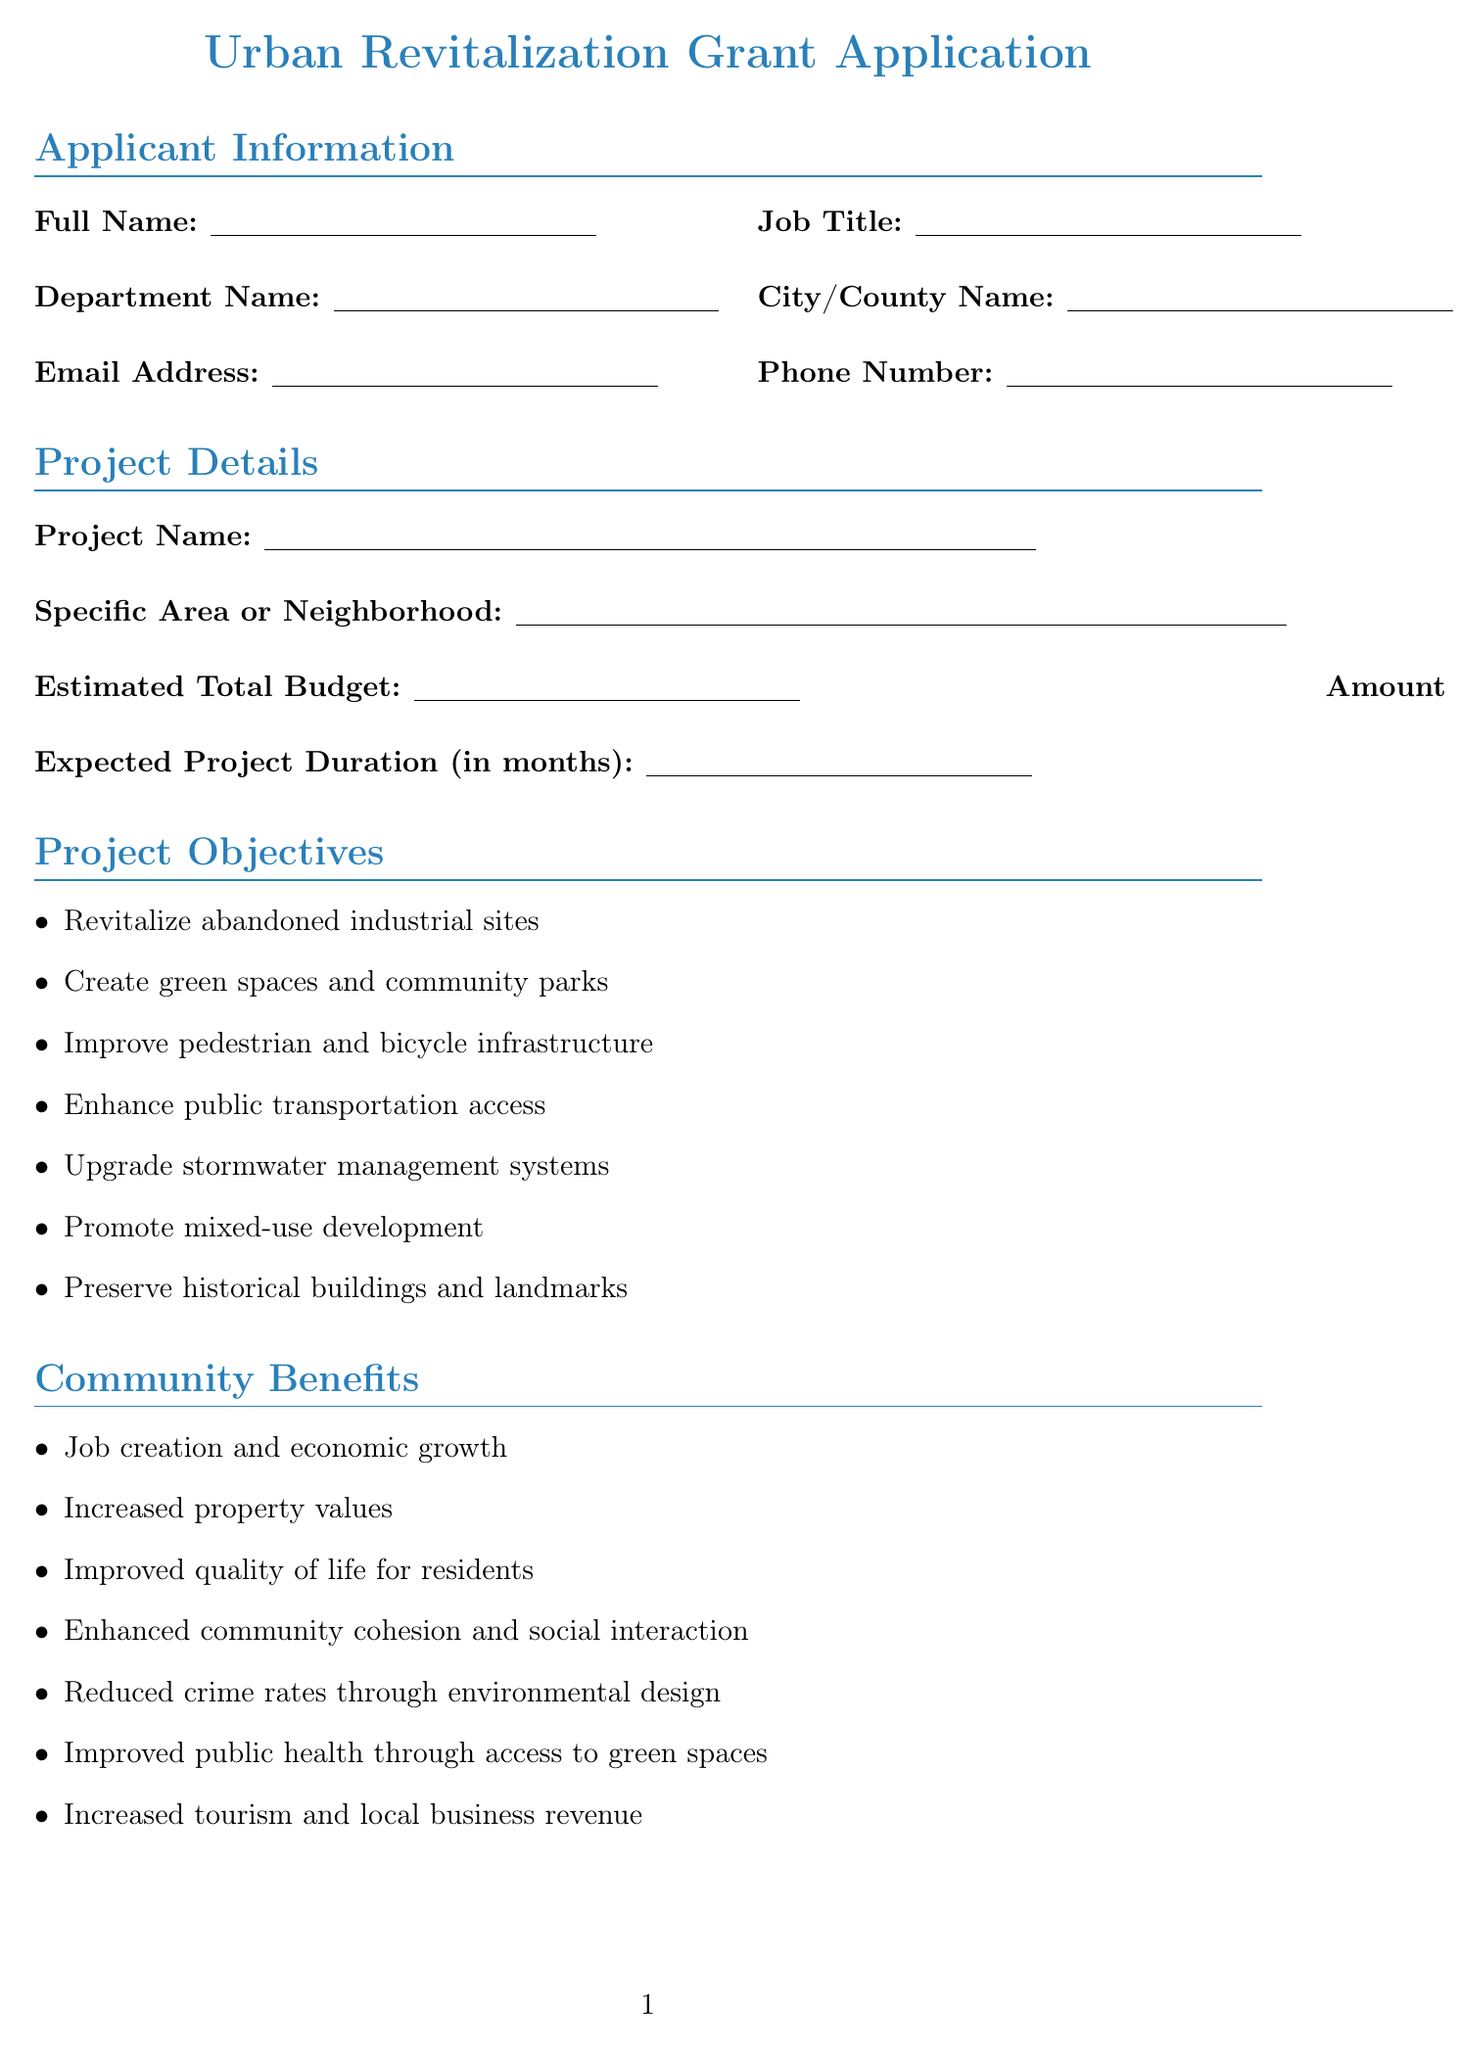what is the project name? The project name is specified in the project details section of the document.
Answer: Project Name how many benefits are listed? There are multiple community benefits listed in the document.
Answer: 7 what is the total budget? The total budget is indicated in the project details section of the document.
Answer: Estimated Total Budget how long is the expected project duration? The expected project duration is mentioned in the project details section.
Answer: Expected Project Duration (in months) which stakeholders are listed for partnerships? The partnerships section includes different organizations that are involved.
Answer: Local Chamber of Commerce, Neighborhood Associations, Environmental Non-Profit Organizations, Historical Preservation Society, Local Universities and Colleges, Regional Planning Commission, State Department of Transportation what infrastructure component involves tree planting? The document lists various infrastructure components, including those related to landscaping.
Answer: Tree planting and landscaping how many community meetings held? The document specifies the number of community meetings held for stakeholder engagement.
Answer: Number of community meetings held what type of grant is requested? The amount requested from the grant reflects the funding type sought in urban revitalization.
Answer: Amount Requested from Grant what are the sustainability measures mentioned? The sustainability measures listed in the document describe the eco-friendly initiatives included in the project.
Answer: Energy-efficient building retrofits, Renewable energy installations, Water conservation systems, Green infrastructure for stormwater management, Electric vehicle charging stations, Waste reduction and recycling programs what is the primary objective of the project? The project objectives highlight the key aims, including the revitalization efforts.
Answer: Revitalize abandoned industrial sites 